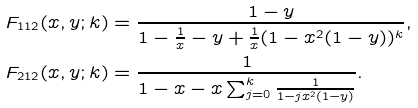<formula> <loc_0><loc_0><loc_500><loc_500>F _ { 1 1 2 } ( x , y ; k ) & = \frac { 1 - y } { 1 - \frac { 1 } { x } - y + \frac { 1 } { x } ( 1 - x ^ { 2 } ( 1 - y ) ) ^ { k } } , \\ F _ { 2 1 2 } ( x , y ; k ) & = \frac { 1 } { 1 - x - x \sum _ { j = 0 } ^ { k } \frac { 1 } { 1 - j x ^ { 2 } ( 1 - y ) } } .</formula> 